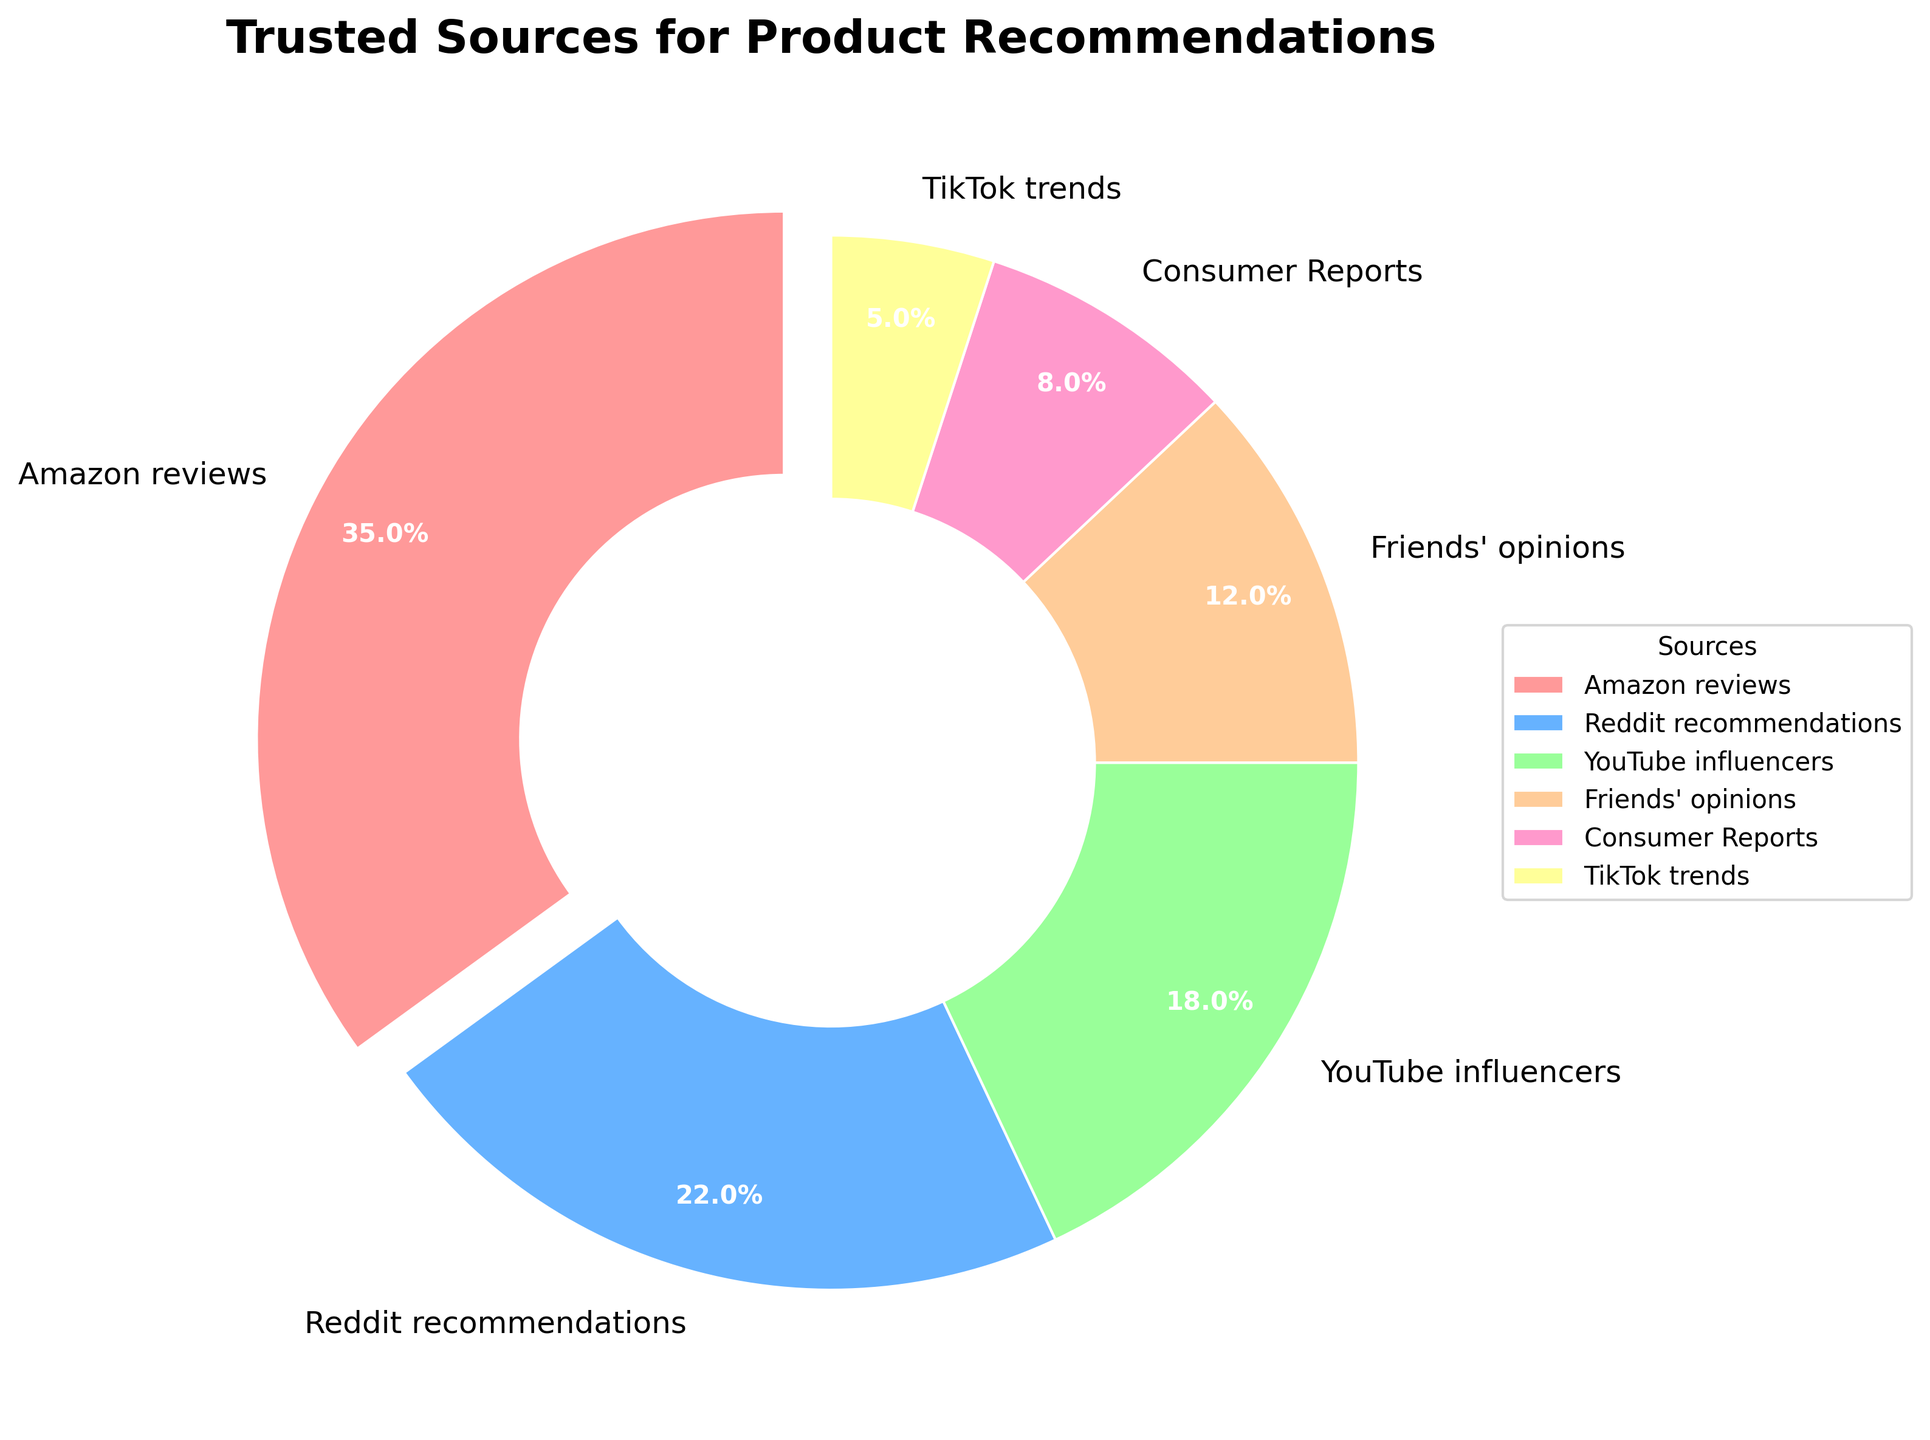What's the most trusted source for product recommendations? The pie chart shows percentages of trust towards various sources. By checking the segment with the largest percentage, we can see that "Amazon reviews" is the most trusted source at 35%.
Answer: Amazon reviews How much more trust do Amazon reviews have compared to Reddit recommendations? By comparing the percentages for Amazon reviews (35%) and Reddit recommendations (22%), we subtract the smaller percentage from the larger one: 35% - 22% = 13%.
Answer: 13% Which source is trusted less: Consumer Reports or TikTok trends? We compare the percentages given for Consumer Reports (8%) and TikTok trends (5%). Since 5% is less than 8%, TikTok trends is the less trusted source.
Answer: TikTok trends What are the combined percentages of trust for YouTube influencers and Friends' opinions? By adding the percentage for YouTube influencers (18%) and Friends' opinions (12%), we get 18% + 12% = 30%.
Answer: 30% What is the difference in trust percentages between the most trusted and least trusted sources? The most trusted source is Amazon reviews (35%) and the least trusted source is TikTok trends (5%). The difference is 35% - 5% = 30%.
Answer: 30% How does YouTube influencers' percentage of trust compare to that of Friends' opinions? YouTube influencers have a trust percentage of 18%, while Friends' opinions have 12%. Since 18% is greater than 12%, YouTube influencers are more trusted.
Answer: YouTube influencers Identify and list the sources trusted by more than 20% of students? By examining the pie chart, sources with percentages greater than 20% are Amazon reviews (35%) and Reddit recommendations (22%).
Answer: Amazon reviews, Reddit recommendations Which source occupies the smallest segment in the pie chart? The smallest segment in the pie chart corresponds to the source with the smallest percentage. TikTok trends have the smallest percentage at 5%.
Answer: TikTok trends Combine the trust percentages of all sources except for Amazon reviews. What is the result? Adding the percentages of Reddit recommendations (22%), YouTube influencers (18%), Friends' opinions (12%), Consumer Reports (8%), and TikTok trends (5%), we get 22% + 18% + 12% + 8% + 5% = 65%.
Answer: 65% What percentage of trust do non-social media-based sources have collectively? (Considering Amazon reviews and Consumer Reports) Adding the percentages for Amazon reviews (35%) and Consumer Reports (8%), we get 35% + 8% = 43%.
Answer: 43% 